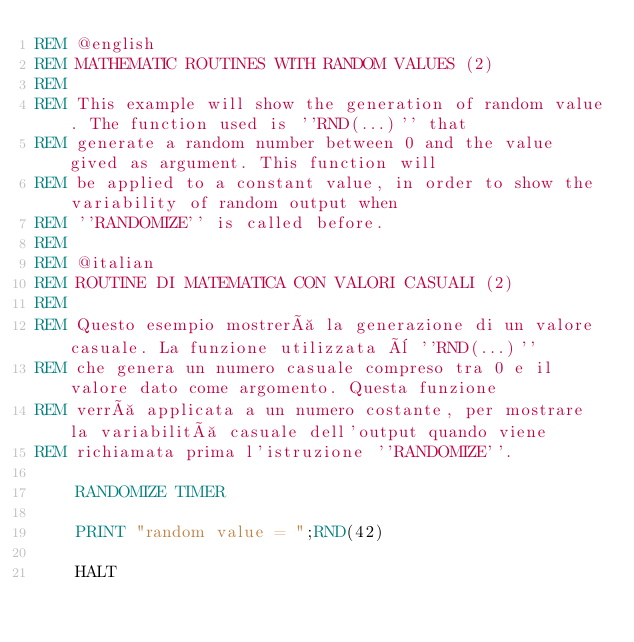<code> <loc_0><loc_0><loc_500><loc_500><_VisualBasic_>REM @english
REM MATHEMATIC ROUTINES WITH RANDOM VALUES (2)
REM
REM This example will show the generation of random value. The function used is ''RND(...)'' that
REM generate a random number between 0 and the value gived as argument. This function will
REM be applied to a constant value, in order to show the variability of random output when
REM ''RANDOMIZE'' is called before.
REM
REM @italian
REM ROUTINE DI MATEMATICA CON VALORI CASUALI (2)
REM
REM Questo esempio mostrerà la generazione di un valore casuale. La funzione utilizzata è ''RND(...)'' 
REM che genera un numero casuale compreso tra 0 e il valore dato come argomento. Questa funzione 
REM verrà applicata a un numero costante, per mostrare la variabilità casuale dell'output quando viene
REM richiamata prima l'istruzione ''RANDOMIZE''.

    RANDOMIZE TIMER
    
    PRINT "random value = ";RND(42)

    HALT</code> 